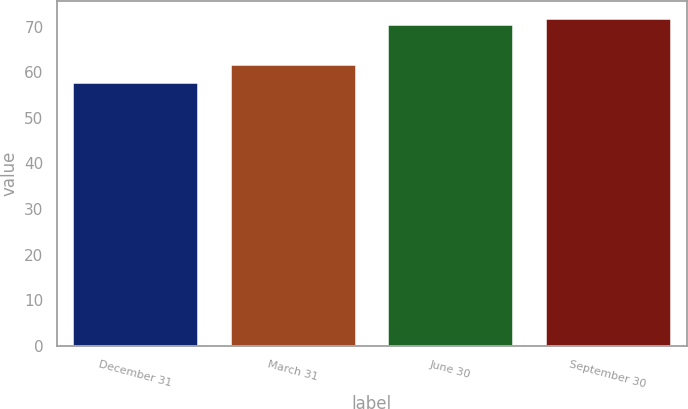Convert chart to OTSL. <chart><loc_0><loc_0><loc_500><loc_500><bar_chart><fcel>December 31<fcel>March 31<fcel>June 30<fcel>September 30<nl><fcel>57.82<fcel>61.74<fcel>70.6<fcel>72.01<nl></chart> 